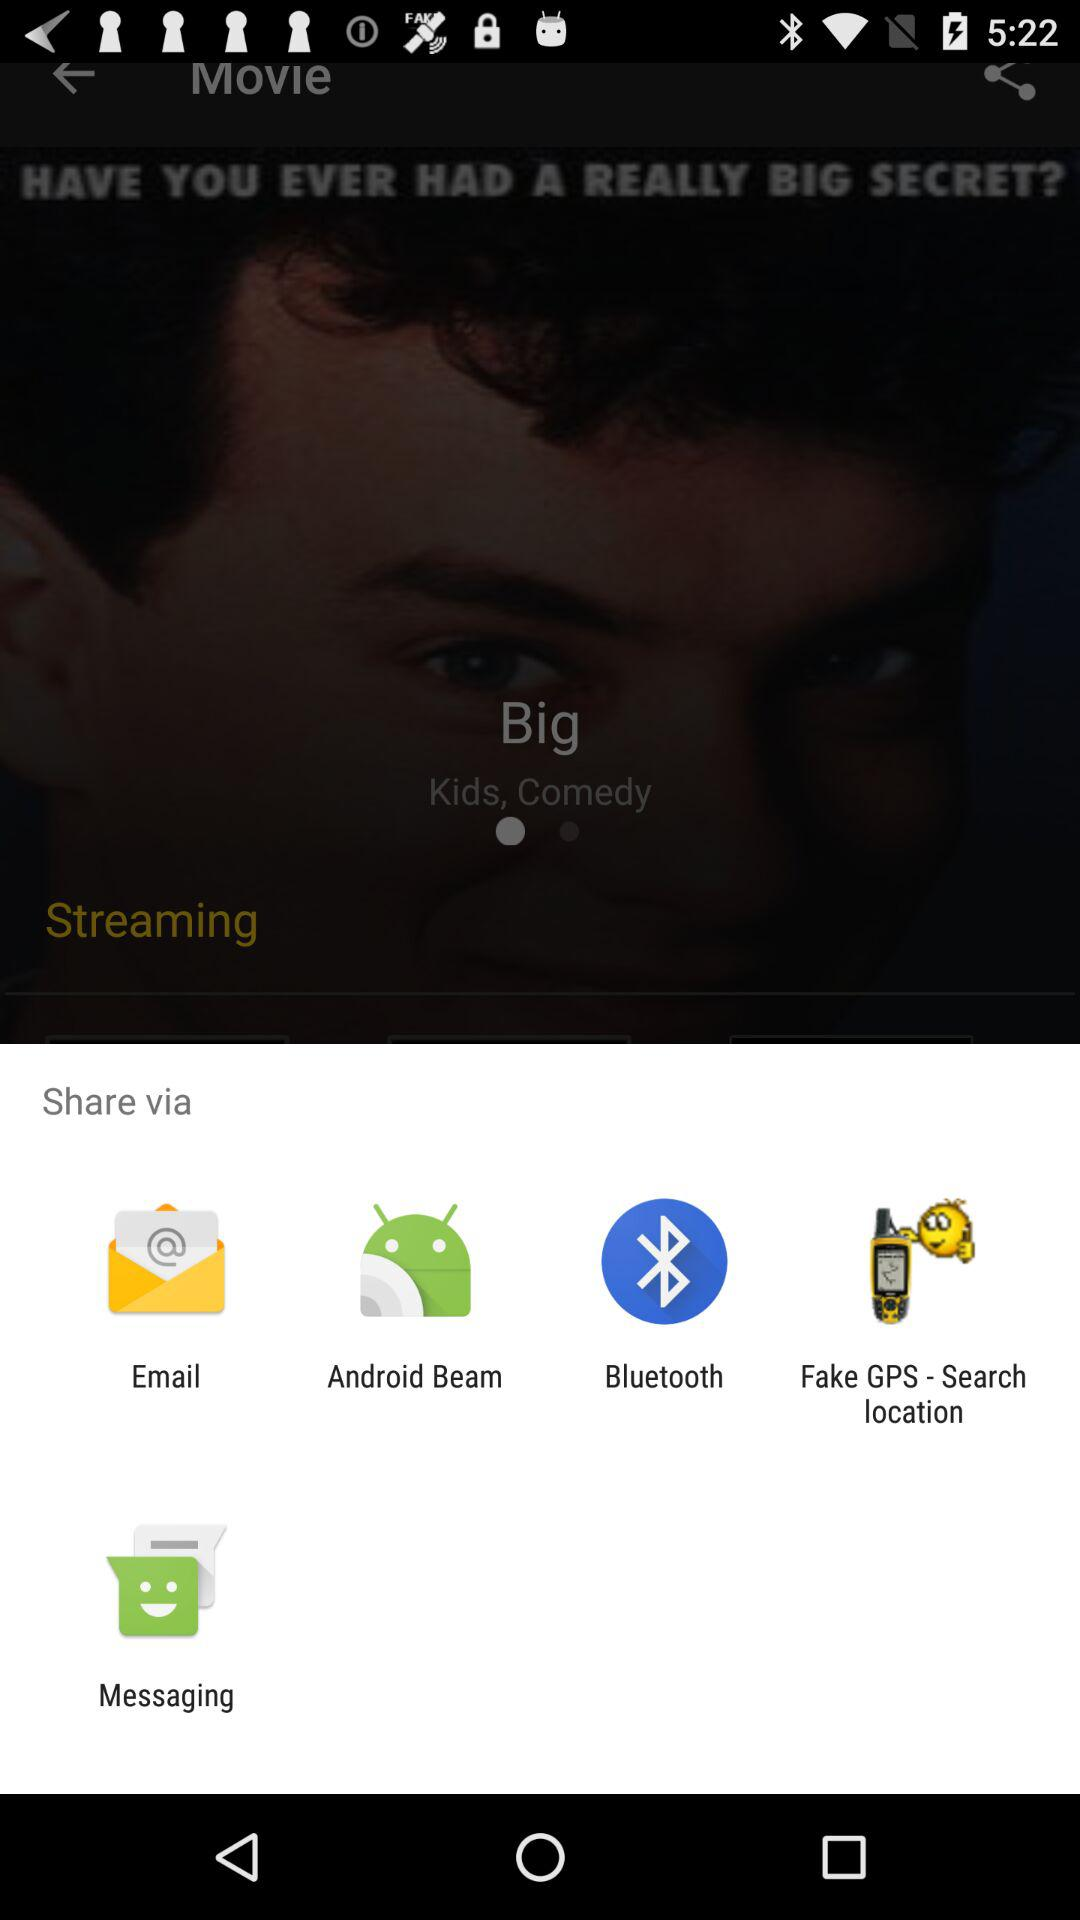Through what app can we share? You can share with "Email", "Android Beam", "Facebook", "Fake GPS - Search location" and "Messaging". 